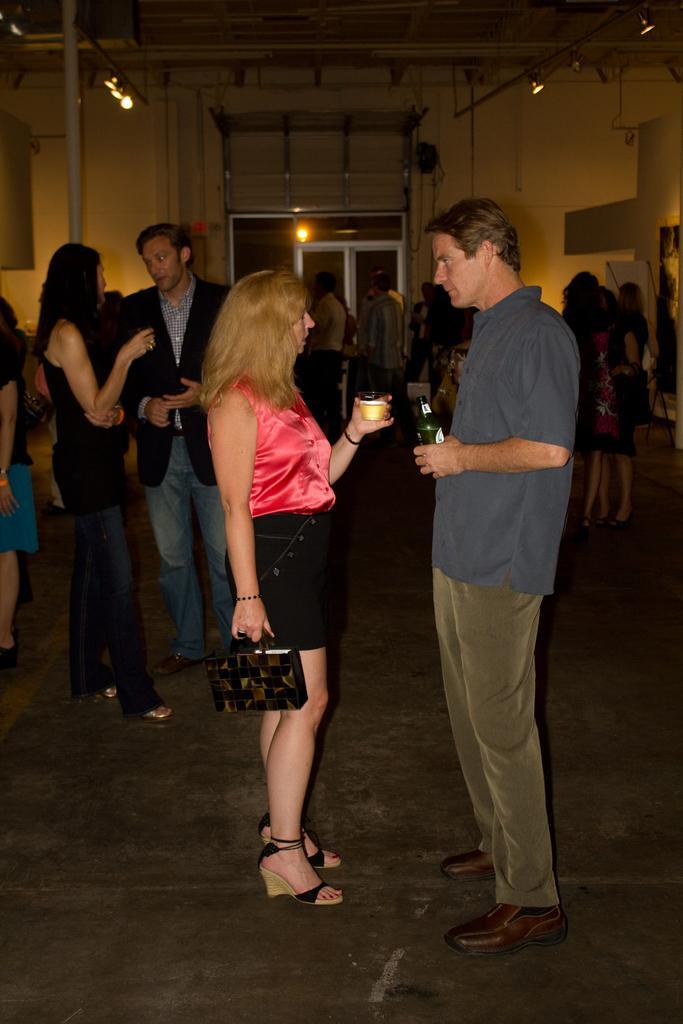Please provide a concise description of this image. In this image I can see a man wearing a shirt pant and shoes Standing and holding a bottle in hand and women wearing a red top and black skirt Standing and holding a cup and a bag in her hands. In the background I can see few other people standing, the wall,few lights, the ceiling and the door. 